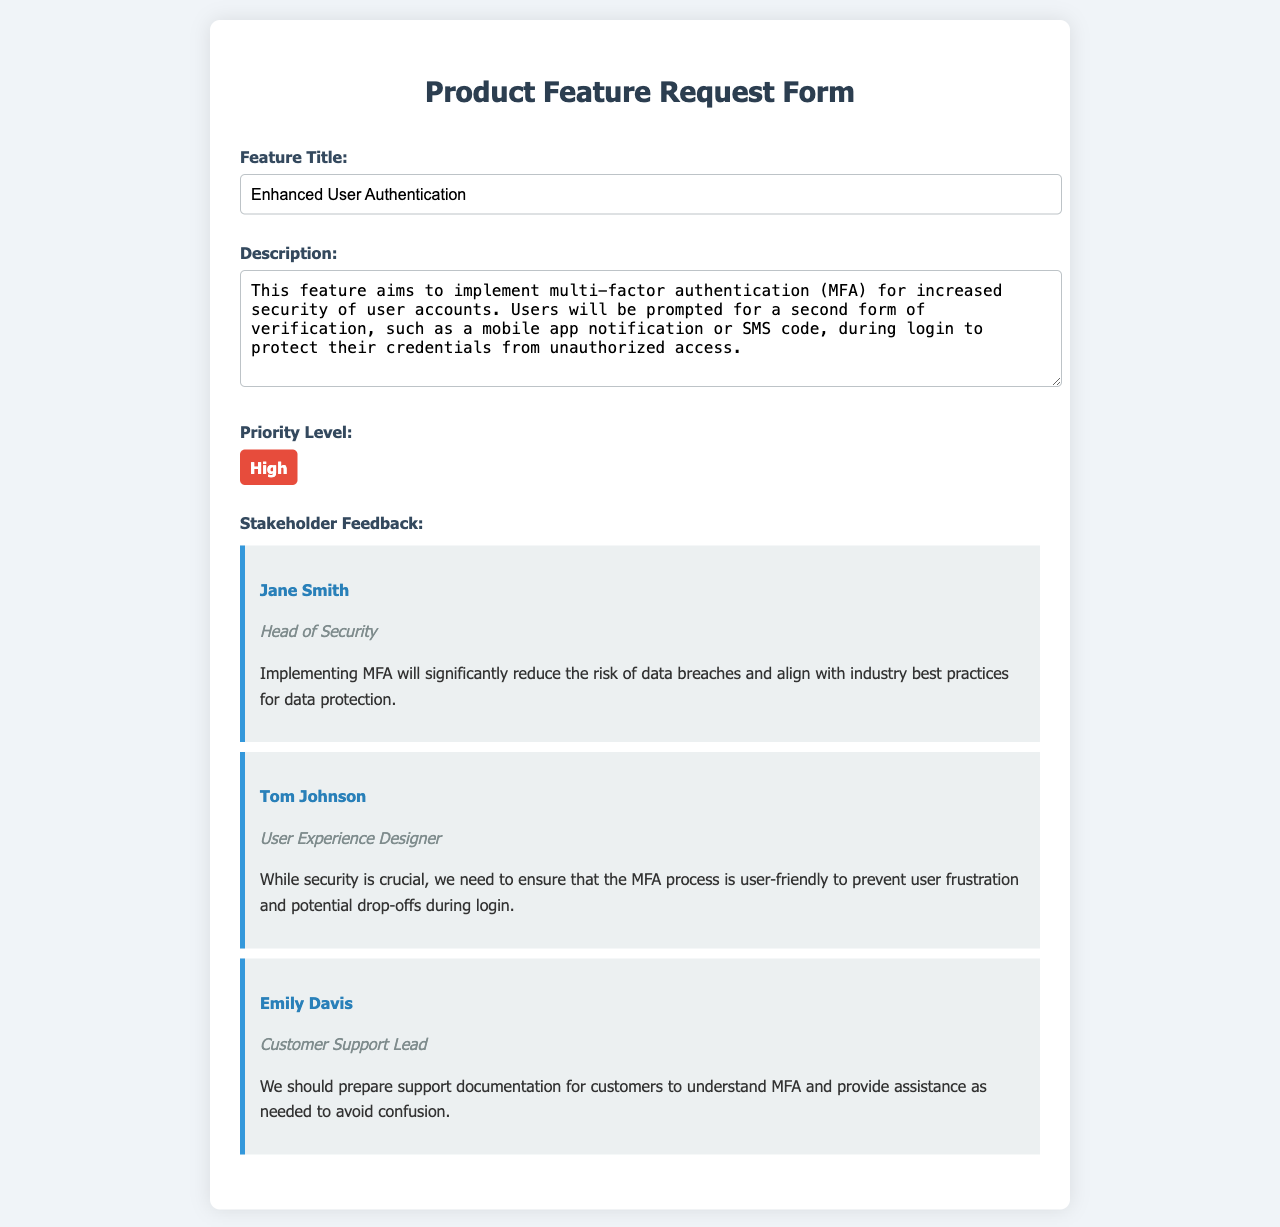what is the feature title? The feature title is specified in the document, which is the main subject of the request.
Answer: Enhanced User Authentication what is the description of the feature? The description provides detailed information about the feature's purpose and functionality as outlined in the document.
Answer: This feature aims to implement multi-factor authentication (MFA) for increased security of user accounts what is the priority level of this feature? The document states the level of urgency or importance assigned to the feature.
Answer: High who is the head of security providing feedback? This identifies the stakeholder who has a relevant role in relation to the feature.
Answer: Jane Smith what does Tom Johnson emphasize in his feedback? This summarizes the main point made by Tom Johnson regarding user experience.
Answer: Ensure the MFA process is user-friendly what is Emily Davis' role? This identifies the professional position of the stakeholder providing feedback.
Answer: Customer Support Lead how many stakeholders provided feedback? This counts the number of distinct feedback contributors listed in the document.
Answer: Three which security feature does the document propose? This specifies the security enhancement being discussed in the feature request.
Answer: Multi-factor authentication (MFA) what is the main benefit mentioned by Jane Smith regarding MFA? This seeks to highlight the key advantage that Jane Smith associates with implementing the feature.
Answer: Reduce the risk of data breaches 